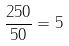<formula> <loc_0><loc_0><loc_500><loc_500>\frac { 2 5 0 } { 5 0 } = 5</formula> 